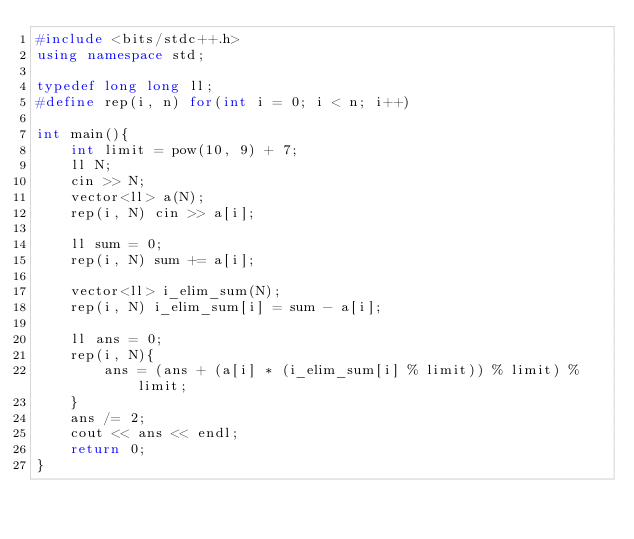<code> <loc_0><loc_0><loc_500><loc_500><_C++_>#include <bits/stdc++.h>
using namespace std;

typedef long long ll;
#define rep(i, n) for(int i = 0; i < n; i++)

int main(){
    int limit = pow(10, 9) + 7;
    ll N;
    cin >> N;
    vector<ll> a(N);
    rep(i, N) cin >> a[i];

    ll sum = 0;
    rep(i, N) sum += a[i];

    vector<ll> i_elim_sum(N);
    rep(i, N) i_elim_sum[i] = sum - a[i];

    ll ans = 0;
    rep(i, N){
        ans = (ans + (a[i] * (i_elim_sum[i] % limit)) % limit) % limit;
    }
    ans /= 2;
    cout << ans << endl;
    return 0;
}</code> 